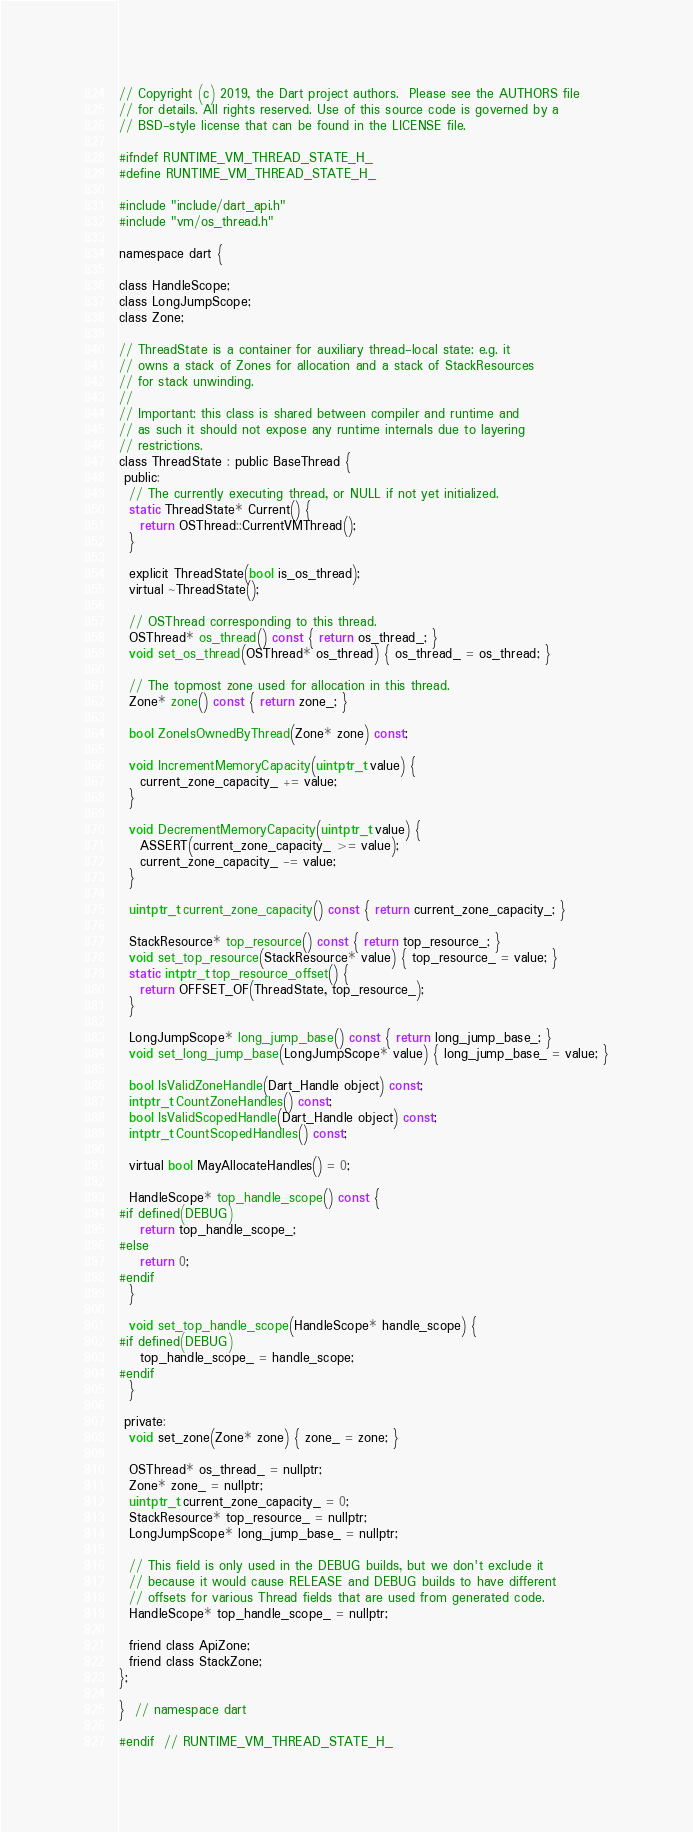<code> <loc_0><loc_0><loc_500><loc_500><_C_>// Copyright (c) 2019, the Dart project authors.  Please see the AUTHORS file
// for details. All rights reserved. Use of this source code is governed by a
// BSD-style license that can be found in the LICENSE file.

#ifndef RUNTIME_VM_THREAD_STATE_H_
#define RUNTIME_VM_THREAD_STATE_H_

#include "include/dart_api.h"
#include "vm/os_thread.h"

namespace dart {

class HandleScope;
class LongJumpScope;
class Zone;

// ThreadState is a container for auxiliary thread-local state: e.g. it
// owns a stack of Zones for allocation and a stack of StackResources
// for stack unwinding.
//
// Important: this class is shared between compiler and runtime and
// as such it should not expose any runtime internals due to layering
// restrictions.
class ThreadState : public BaseThread {
 public:
  // The currently executing thread, or NULL if not yet initialized.
  static ThreadState* Current() {
    return OSThread::CurrentVMThread();
  }

  explicit ThreadState(bool is_os_thread);
  virtual ~ThreadState();

  // OSThread corresponding to this thread.
  OSThread* os_thread() const { return os_thread_; }
  void set_os_thread(OSThread* os_thread) { os_thread_ = os_thread; }

  // The topmost zone used for allocation in this thread.
  Zone* zone() const { return zone_; }

  bool ZoneIsOwnedByThread(Zone* zone) const;

  void IncrementMemoryCapacity(uintptr_t value) {
    current_zone_capacity_ += value;
  }

  void DecrementMemoryCapacity(uintptr_t value) {
    ASSERT(current_zone_capacity_ >= value);
    current_zone_capacity_ -= value;
  }

  uintptr_t current_zone_capacity() const { return current_zone_capacity_; }

  StackResource* top_resource() const { return top_resource_; }
  void set_top_resource(StackResource* value) { top_resource_ = value; }
  static intptr_t top_resource_offset() {
    return OFFSET_OF(ThreadState, top_resource_);
  }

  LongJumpScope* long_jump_base() const { return long_jump_base_; }
  void set_long_jump_base(LongJumpScope* value) { long_jump_base_ = value; }

  bool IsValidZoneHandle(Dart_Handle object) const;
  intptr_t CountZoneHandles() const;
  bool IsValidScopedHandle(Dart_Handle object) const;
  intptr_t CountScopedHandles() const;

  virtual bool MayAllocateHandles() = 0;

  HandleScope* top_handle_scope() const {
#if defined(DEBUG)
    return top_handle_scope_;
#else
    return 0;
#endif
  }

  void set_top_handle_scope(HandleScope* handle_scope) {
#if defined(DEBUG)
    top_handle_scope_ = handle_scope;
#endif
  }

 private:
  void set_zone(Zone* zone) { zone_ = zone; }

  OSThread* os_thread_ = nullptr;
  Zone* zone_ = nullptr;
  uintptr_t current_zone_capacity_ = 0;
  StackResource* top_resource_ = nullptr;
  LongJumpScope* long_jump_base_ = nullptr;

  // This field is only used in the DEBUG builds, but we don't exclude it
  // because it would cause RELEASE and DEBUG builds to have different
  // offsets for various Thread fields that are used from generated code.
  HandleScope* top_handle_scope_ = nullptr;

  friend class ApiZone;
  friend class StackZone;
};

}  // namespace dart

#endif  // RUNTIME_VM_THREAD_STATE_H_
</code> 